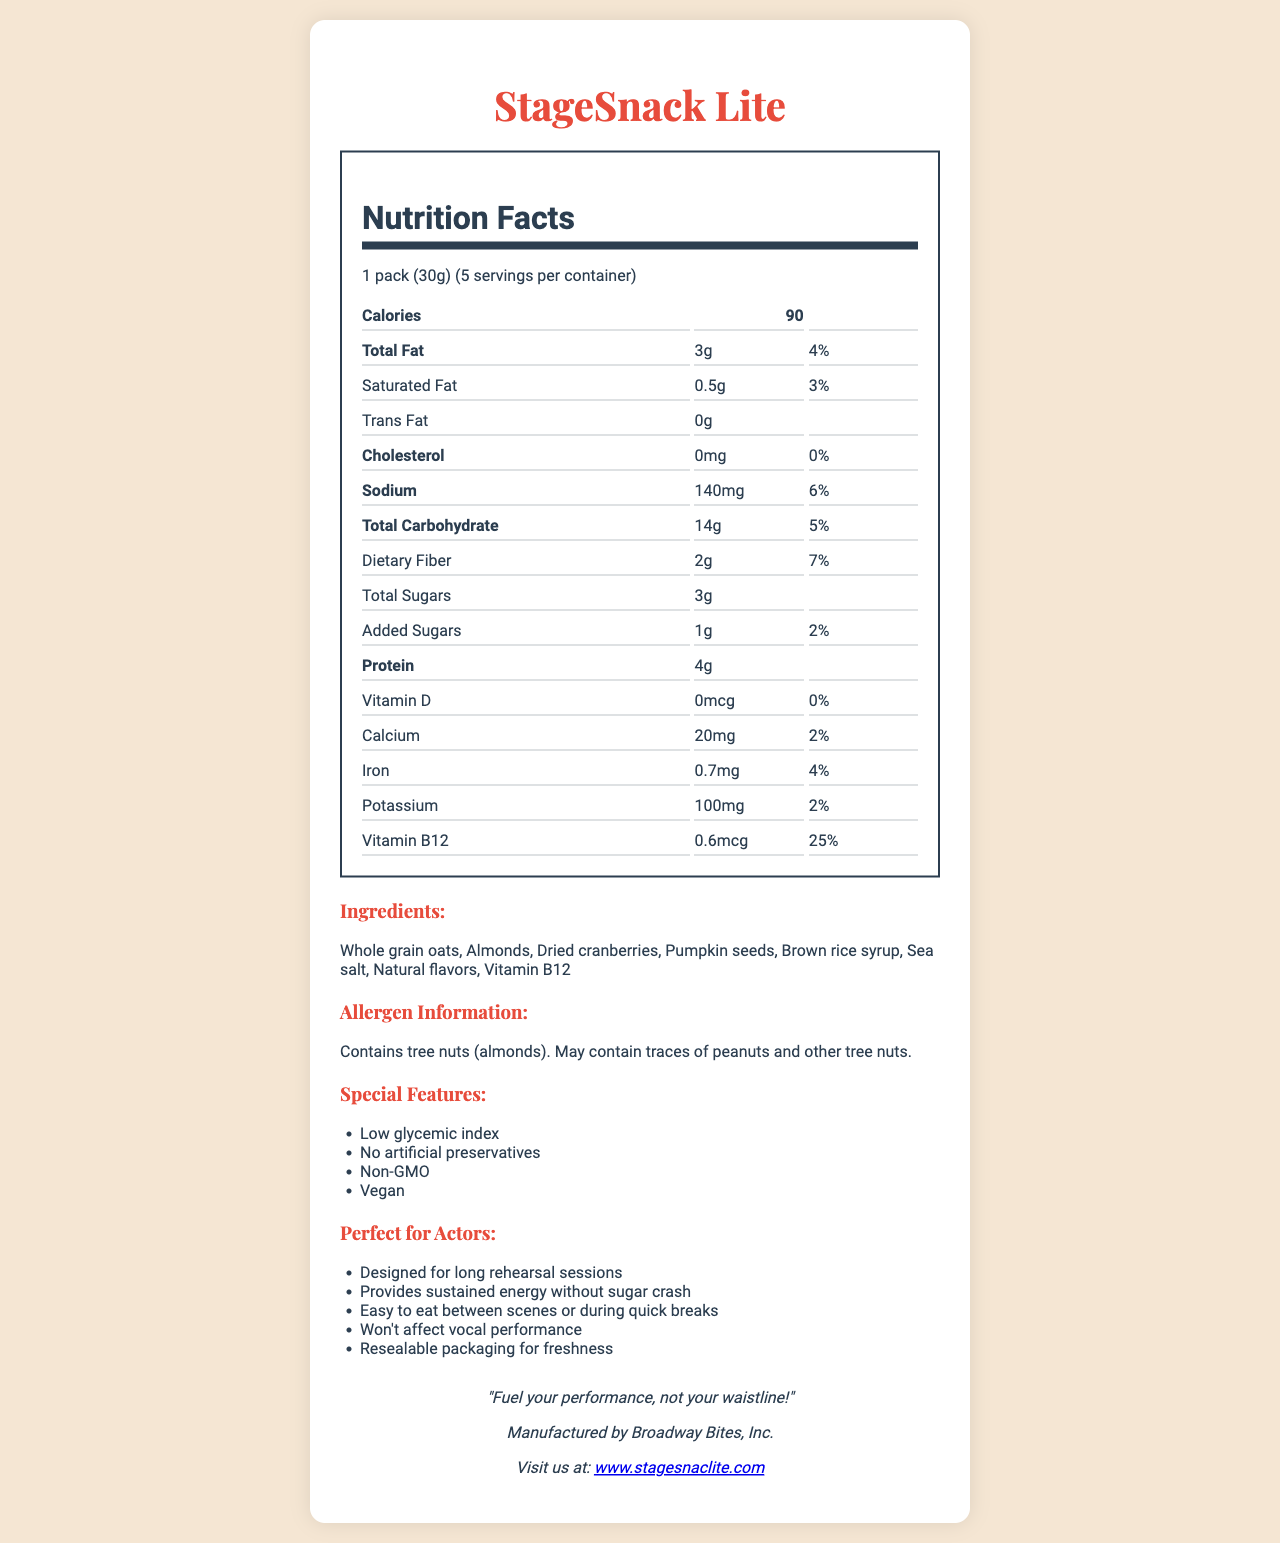what is the serving size? The serving size is indicated at the top of the nutrition label within the rendered document.
Answer: 1 pack (30g) how many servings are in a container? This information is provided right next to the serving size details in the document.
Answer: 5 servings how much protein is in one serving? The amount of protein per serving can be found under the "Protein" section of the nutrition label.
Answer: 4g what is the total amount of fat in one serving? The total amount of fat is listed under the "Total Fat" section in the document.
Answer: 3g what ingredients are used in StageSnack Lite? The ingredients are listed in a specific section titled "Ingredients" within the document.
Answer: Whole grain oats, Almonds, Dried cranberries, Pumpkin seeds, Brown rice syrup, Sea salt, Natural flavors, Vitamin B12 how many calories are in one pack? The calorie count per serving is listed at the top of the nutrition facts section.
Answer: 90 calories how much added sugar does one serving contain? The amount of added sugars is found under the "Added Sugars" section in the document.
Answer: 1g what is the sodium content per serving? The sodium content is listed under the "Sodium" section of the nutrition label.
Answer: 140mg does this product contain any tree nuts? (Yes/No) The allergen information specifies that the product contains tree nuts (almonds).
Answer: Yes which of the following is not a special feature of StageSnack Lite? A. Non-GMO B. Gluten-Free C. No artificial preservatives D. Vegan Gluten-Free is not listed among the special features in the "Special Features" section.
Answer: B. Gluten-Free what percentage of the daily value for iron does one serving provide? The daily value percentage for iron is listed under the "Iron" section of the nutrition facts.
Answer: 4% which nutrient has the highest daily value percentage in this product? A. Vitamin D B. Iron C. Vitamin B12 D. Potassium Vitamin B12 has the highest daily value percentage at 25%, as seen in the "Vitamin B12" section.
Answer: C. Vitamin B12 how much dietary fiber is in one serving? The dietary fiber content per serving is listed under the "Dietary Fiber" section in the nutrition label.
Answer: 2g what is StageSnack Lite designed for? This information is specifically mentioned under the "Perfect for Actors" section in the document.
Answer: Designed for long rehearsal sessions who manufactures StageSnack Lite? The manufacturer is listed in the "Brand Info" section of the document.
Answer: Broadway Bites, Inc. summarize the main idea of the document The document provides a detailed overview of the nutritional content, ingredients, special features, and specific benefits for actors, along with manufacturer and brand information.
Answer: StageSnack Lite is a low-calorie snack designed specifically for actors during long rehearsal sessions, providing sustained energy without affecting vocal performance. It contains healthy ingredients, has several special features like being non-GMO and vegan, and provides detailed nutritional information. how many grams of total carbohydrates does five servings contain? The document only provides information for one serving, not the total grams for five servings.
Answer: Cannot be determined 